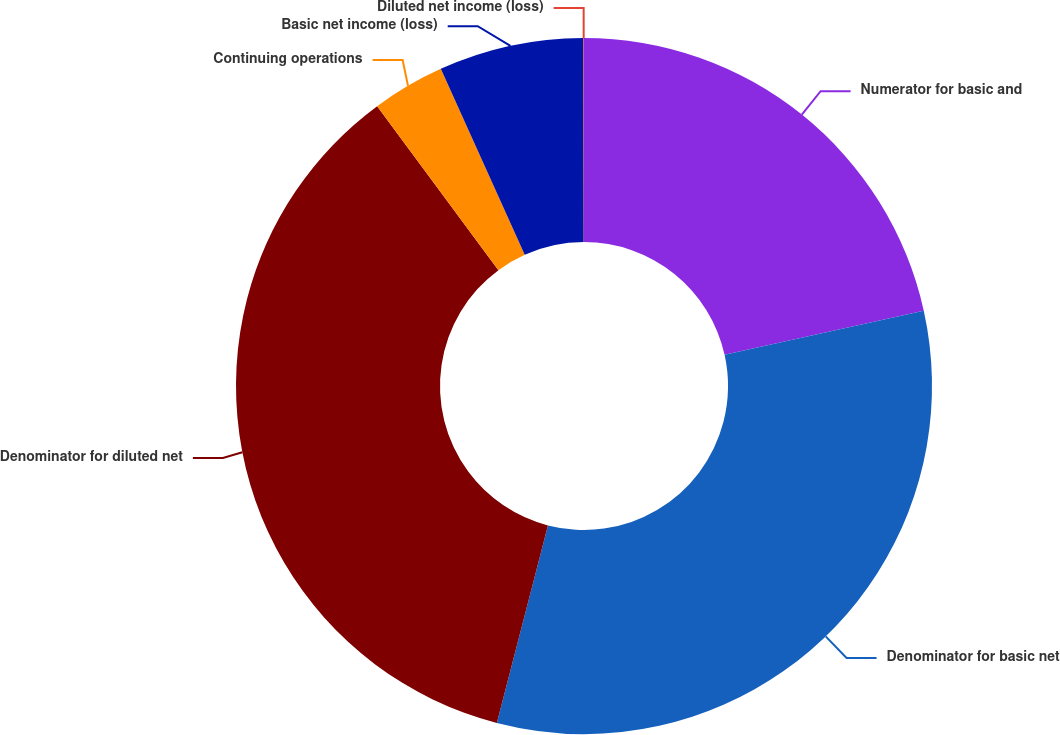Convert chart. <chart><loc_0><loc_0><loc_500><loc_500><pie_chart><fcel>Numerator for basic and<fcel>Denominator for basic net<fcel>Denominator for diluted net<fcel>Continuing operations<fcel>Basic net income (loss)<fcel>Diluted net income (loss)<nl><fcel>21.53%<fcel>32.5%<fcel>35.84%<fcel>3.38%<fcel>6.72%<fcel>0.03%<nl></chart> 